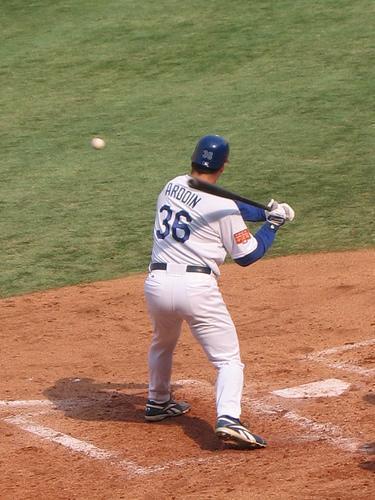How many baseballs are there?
Give a very brief answer. 1. 